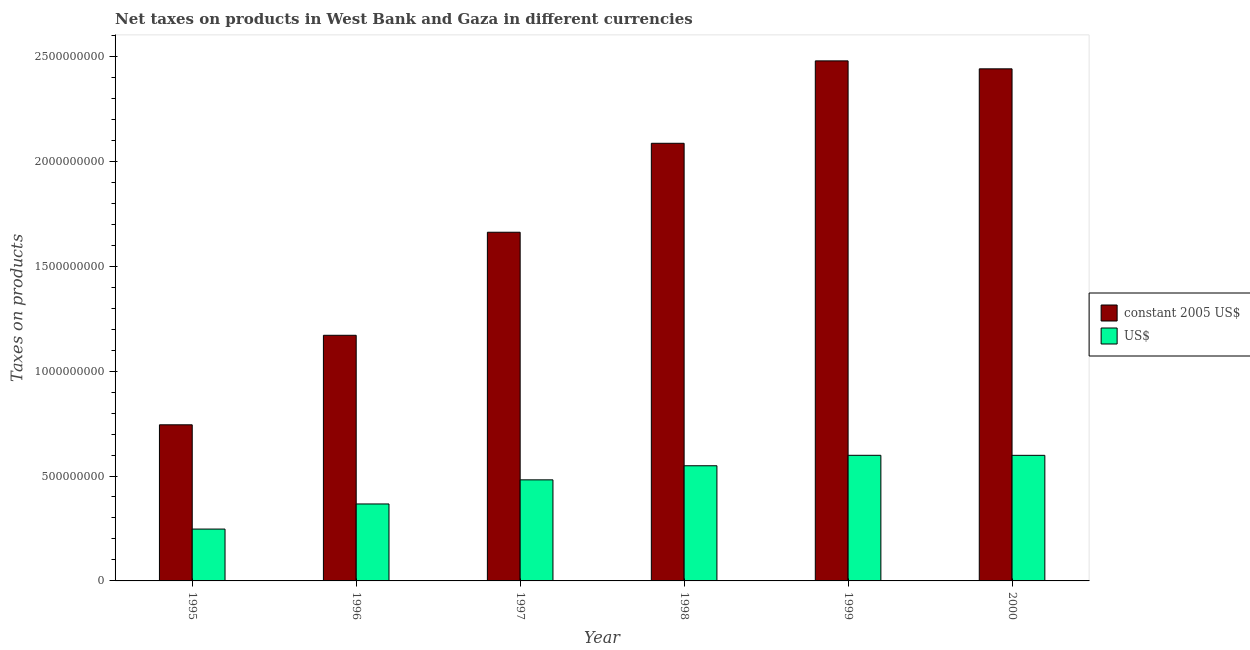How many groups of bars are there?
Your answer should be very brief. 6. Are the number of bars per tick equal to the number of legend labels?
Offer a terse response. Yes. Are the number of bars on each tick of the X-axis equal?
Make the answer very short. Yes. How many bars are there on the 4th tick from the left?
Make the answer very short. 2. How many bars are there on the 6th tick from the right?
Your answer should be compact. 2. What is the net taxes in us$ in 1996?
Keep it short and to the point. 3.67e+08. Across all years, what is the maximum net taxes in us$?
Your response must be concise. 5.99e+08. Across all years, what is the minimum net taxes in constant 2005 us$?
Make the answer very short. 7.44e+08. In which year was the net taxes in us$ maximum?
Your answer should be compact. 1999. In which year was the net taxes in us$ minimum?
Provide a succinct answer. 1995. What is the total net taxes in us$ in the graph?
Provide a short and direct response. 2.84e+09. What is the difference between the net taxes in constant 2005 us$ in 1996 and that in 1999?
Your answer should be compact. -1.31e+09. What is the difference between the net taxes in constant 2005 us$ in 1995 and the net taxes in us$ in 2000?
Give a very brief answer. -1.70e+09. What is the average net taxes in us$ per year?
Your response must be concise. 4.74e+08. In the year 1996, what is the difference between the net taxes in us$ and net taxes in constant 2005 us$?
Offer a very short reply. 0. In how many years, is the net taxes in constant 2005 us$ greater than 2400000000 units?
Your answer should be very brief. 2. What is the ratio of the net taxes in us$ in 1997 to that in 2000?
Ensure brevity in your answer.  0.8. Is the difference between the net taxes in constant 2005 us$ in 1996 and 1999 greater than the difference between the net taxes in us$ in 1996 and 1999?
Give a very brief answer. No. What is the difference between the highest and the second highest net taxes in us$?
Keep it short and to the point. 1.47e+05. What is the difference between the highest and the lowest net taxes in us$?
Offer a terse response. 3.52e+08. In how many years, is the net taxes in us$ greater than the average net taxes in us$ taken over all years?
Your response must be concise. 4. Is the sum of the net taxes in us$ in 1996 and 1998 greater than the maximum net taxes in constant 2005 us$ across all years?
Provide a short and direct response. Yes. What does the 2nd bar from the left in 1995 represents?
Provide a short and direct response. US$. What does the 2nd bar from the right in 1999 represents?
Your answer should be very brief. Constant 2005 us$. How many bars are there?
Your response must be concise. 12. Are all the bars in the graph horizontal?
Make the answer very short. No. How many years are there in the graph?
Keep it short and to the point. 6. What is the difference between two consecutive major ticks on the Y-axis?
Your response must be concise. 5.00e+08. Are the values on the major ticks of Y-axis written in scientific E-notation?
Your response must be concise. No. How many legend labels are there?
Provide a succinct answer. 2. What is the title of the graph?
Your response must be concise. Net taxes on products in West Bank and Gaza in different currencies. Does "Age 15+" appear as one of the legend labels in the graph?
Give a very brief answer. No. What is the label or title of the Y-axis?
Ensure brevity in your answer.  Taxes on products. What is the Taxes on products in constant 2005 US$ in 1995?
Your response must be concise. 7.44e+08. What is the Taxes on products in US$ in 1995?
Your answer should be very brief. 2.47e+08. What is the Taxes on products in constant 2005 US$ in 1996?
Your answer should be compact. 1.17e+09. What is the Taxes on products of US$ in 1996?
Provide a succinct answer. 3.67e+08. What is the Taxes on products in constant 2005 US$ in 1997?
Offer a very short reply. 1.66e+09. What is the Taxes on products in US$ in 1997?
Give a very brief answer. 4.82e+08. What is the Taxes on products in constant 2005 US$ in 1998?
Your response must be concise. 2.09e+09. What is the Taxes on products of US$ in 1998?
Give a very brief answer. 5.49e+08. What is the Taxes on products in constant 2005 US$ in 1999?
Provide a succinct answer. 2.48e+09. What is the Taxes on products of US$ in 1999?
Your answer should be compact. 5.99e+08. What is the Taxes on products in constant 2005 US$ in 2000?
Provide a short and direct response. 2.44e+09. What is the Taxes on products of US$ in 2000?
Provide a succinct answer. 5.99e+08. Across all years, what is the maximum Taxes on products of constant 2005 US$?
Keep it short and to the point. 2.48e+09. Across all years, what is the maximum Taxes on products in US$?
Give a very brief answer. 5.99e+08. Across all years, what is the minimum Taxes on products of constant 2005 US$?
Your response must be concise. 7.44e+08. Across all years, what is the minimum Taxes on products of US$?
Offer a very short reply. 2.47e+08. What is the total Taxes on products in constant 2005 US$ in the graph?
Give a very brief answer. 1.06e+1. What is the total Taxes on products of US$ in the graph?
Give a very brief answer. 2.84e+09. What is the difference between the Taxes on products in constant 2005 US$ in 1995 and that in 1996?
Your response must be concise. -4.27e+08. What is the difference between the Taxes on products in US$ in 1995 and that in 1996?
Give a very brief answer. -1.20e+08. What is the difference between the Taxes on products of constant 2005 US$ in 1995 and that in 1997?
Give a very brief answer. -9.18e+08. What is the difference between the Taxes on products of US$ in 1995 and that in 1997?
Ensure brevity in your answer.  -2.35e+08. What is the difference between the Taxes on products of constant 2005 US$ in 1995 and that in 1998?
Give a very brief answer. -1.34e+09. What is the difference between the Taxes on products in US$ in 1995 and that in 1998?
Offer a terse response. -3.02e+08. What is the difference between the Taxes on products of constant 2005 US$ in 1995 and that in 1999?
Your response must be concise. -1.73e+09. What is the difference between the Taxes on products of US$ in 1995 and that in 1999?
Offer a very short reply. -3.52e+08. What is the difference between the Taxes on products of constant 2005 US$ in 1995 and that in 2000?
Your answer should be very brief. -1.70e+09. What is the difference between the Taxes on products of US$ in 1995 and that in 2000?
Give a very brief answer. -3.52e+08. What is the difference between the Taxes on products of constant 2005 US$ in 1996 and that in 1997?
Your response must be concise. -4.91e+08. What is the difference between the Taxes on products of US$ in 1996 and that in 1997?
Offer a very short reply. -1.15e+08. What is the difference between the Taxes on products in constant 2005 US$ in 1996 and that in 1998?
Provide a short and direct response. -9.15e+08. What is the difference between the Taxes on products of US$ in 1996 and that in 1998?
Provide a short and direct response. -1.82e+08. What is the difference between the Taxes on products of constant 2005 US$ in 1996 and that in 1999?
Give a very brief answer. -1.31e+09. What is the difference between the Taxes on products of US$ in 1996 and that in 1999?
Provide a succinct answer. -2.32e+08. What is the difference between the Taxes on products of constant 2005 US$ in 1996 and that in 2000?
Make the answer very short. -1.27e+09. What is the difference between the Taxes on products in US$ in 1996 and that in 2000?
Ensure brevity in your answer.  -2.32e+08. What is the difference between the Taxes on products in constant 2005 US$ in 1997 and that in 1998?
Keep it short and to the point. -4.24e+08. What is the difference between the Taxes on products of US$ in 1997 and that in 1998?
Ensure brevity in your answer.  -6.71e+07. What is the difference between the Taxes on products in constant 2005 US$ in 1997 and that in 1999?
Your answer should be compact. -8.17e+08. What is the difference between the Taxes on products of US$ in 1997 and that in 1999?
Offer a terse response. -1.17e+08. What is the difference between the Taxes on products in constant 2005 US$ in 1997 and that in 2000?
Keep it short and to the point. -7.79e+08. What is the difference between the Taxes on products in US$ in 1997 and that in 2000?
Make the answer very short. -1.17e+08. What is the difference between the Taxes on products in constant 2005 US$ in 1998 and that in 1999?
Ensure brevity in your answer.  -3.93e+08. What is the difference between the Taxes on products of US$ in 1998 and that in 1999?
Keep it short and to the point. -4.99e+07. What is the difference between the Taxes on products of constant 2005 US$ in 1998 and that in 2000?
Offer a very short reply. -3.55e+08. What is the difference between the Taxes on products in US$ in 1998 and that in 2000?
Provide a short and direct response. -4.97e+07. What is the difference between the Taxes on products of constant 2005 US$ in 1999 and that in 2000?
Offer a terse response. 3.80e+07. What is the difference between the Taxes on products of US$ in 1999 and that in 2000?
Keep it short and to the point. 1.47e+05. What is the difference between the Taxes on products in constant 2005 US$ in 1995 and the Taxes on products in US$ in 1996?
Provide a short and direct response. 3.77e+08. What is the difference between the Taxes on products of constant 2005 US$ in 1995 and the Taxes on products of US$ in 1997?
Your answer should be compact. 2.62e+08. What is the difference between the Taxes on products in constant 2005 US$ in 1995 and the Taxes on products in US$ in 1998?
Provide a succinct answer. 1.95e+08. What is the difference between the Taxes on products in constant 2005 US$ in 1995 and the Taxes on products in US$ in 1999?
Keep it short and to the point. 1.45e+08. What is the difference between the Taxes on products of constant 2005 US$ in 1995 and the Taxes on products of US$ in 2000?
Offer a terse response. 1.45e+08. What is the difference between the Taxes on products of constant 2005 US$ in 1996 and the Taxes on products of US$ in 1997?
Provide a short and direct response. 6.89e+08. What is the difference between the Taxes on products in constant 2005 US$ in 1996 and the Taxes on products in US$ in 1998?
Keep it short and to the point. 6.22e+08. What is the difference between the Taxes on products of constant 2005 US$ in 1996 and the Taxes on products of US$ in 1999?
Offer a terse response. 5.72e+08. What is the difference between the Taxes on products in constant 2005 US$ in 1996 and the Taxes on products in US$ in 2000?
Ensure brevity in your answer.  5.72e+08. What is the difference between the Taxes on products in constant 2005 US$ in 1997 and the Taxes on products in US$ in 1998?
Your response must be concise. 1.11e+09. What is the difference between the Taxes on products of constant 2005 US$ in 1997 and the Taxes on products of US$ in 1999?
Keep it short and to the point. 1.06e+09. What is the difference between the Taxes on products in constant 2005 US$ in 1997 and the Taxes on products in US$ in 2000?
Your answer should be very brief. 1.06e+09. What is the difference between the Taxes on products in constant 2005 US$ in 1998 and the Taxes on products in US$ in 1999?
Your response must be concise. 1.49e+09. What is the difference between the Taxes on products of constant 2005 US$ in 1998 and the Taxes on products of US$ in 2000?
Your answer should be compact. 1.49e+09. What is the difference between the Taxes on products in constant 2005 US$ in 1999 and the Taxes on products in US$ in 2000?
Provide a short and direct response. 1.88e+09. What is the average Taxes on products of constant 2005 US$ per year?
Give a very brief answer. 1.76e+09. What is the average Taxes on products of US$ per year?
Ensure brevity in your answer.  4.74e+08. In the year 1995, what is the difference between the Taxes on products of constant 2005 US$ and Taxes on products of US$?
Your answer should be very brief. 4.97e+08. In the year 1996, what is the difference between the Taxes on products of constant 2005 US$ and Taxes on products of US$?
Your answer should be very brief. 8.04e+08. In the year 1997, what is the difference between the Taxes on products of constant 2005 US$ and Taxes on products of US$?
Your answer should be very brief. 1.18e+09. In the year 1998, what is the difference between the Taxes on products of constant 2005 US$ and Taxes on products of US$?
Provide a short and direct response. 1.54e+09. In the year 1999, what is the difference between the Taxes on products in constant 2005 US$ and Taxes on products in US$?
Your answer should be very brief. 1.88e+09. In the year 2000, what is the difference between the Taxes on products of constant 2005 US$ and Taxes on products of US$?
Offer a very short reply. 1.84e+09. What is the ratio of the Taxes on products in constant 2005 US$ in 1995 to that in 1996?
Your response must be concise. 0.64. What is the ratio of the Taxes on products in US$ in 1995 to that in 1996?
Your answer should be compact. 0.67. What is the ratio of the Taxes on products of constant 2005 US$ in 1995 to that in 1997?
Provide a short and direct response. 0.45. What is the ratio of the Taxes on products in US$ in 1995 to that in 1997?
Give a very brief answer. 0.51. What is the ratio of the Taxes on products of constant 2005 US$ in 1995 to that in 1998?
Your answer should be compact. 0.36. What is the ratio of the Taxes on products of US$ in 1995 to that in 1998?
Offer a very short reply. 0.45. What is the ratio of the Taxes on products in constant 2005 US$ in 1995 to that in 1999?
Your answer should be very brief. 0.3. What is the ratio of the Taxes on products of US$ in 1995 to that in 1999?
Keep it short and to the point. 0.41. What is the ratio of the Taxes on products in constant 2005 US$ in 1995 to that in 2000?
Give a very brief answer. 0.3. What is the ratio of the Taxes on products in US$ in 1995 to that in 2000?
Ensure brevity in your answer.  0.41. What is the ratio of the Taxes on products of constant 2005 US$ in 1996 to that in 1997?
Provide a succinct answer. 0.7. What is the ratio of the Taxes on products in US$ in 1996 to that in 1997?
Provide a short and direct response. 0.76. What is the ratio of the Taxes on products in constant 2005 US$ in 1996 to that in 1998?
Your answer should be very brief. 0.56. What is the ratio of the Taxes on products in US$ in 1996 to that in 1998?
Provide a short and direct response. 0.67. What is the ratio of the Taxes on products of constant 2005 US$ in 1996 to that in 1999?
Provide a short and direct response. 0.47. What is the ratio of the Taxes on products of US$ in 1996 to that in 1999?
Provide a succinct answer. 0.61. What is the ratio of the Taxes on products in constant 2005 US$ in 1996 to that in 2000?
Offer a very short reply. 0.48. What is the ratio of the Taxes on products of US$ in 1996 to that in 2000?
Give a very brief answer. 0.61. What is the ratio of the Taxes on products of constant 2005 US$ in 1997 to that in 1998?
Ensure brevity in your answer.  0.8. What is the ratio of the Taxes on products in US$ in 1997 to that in 1998?
Offer a very short reply. 0.88. What is the ratio of the Taxes on products in constant 2005 US$ in 1997 to that in 1999?
Offer a terse response. 0.67. What is the ratio of the Taxes on products of US$ in 1997 to that in 1999?
Offer a very short reply. 0.8. What is the ratio of the Taxes on products of constant 2005 US$ in 1997 to that in 2000?
Ensure brevity in your answer.  0.68. What is the ratio of the Taxes on products of US$ in 1997 to that in 2000?
Make the answer very short. 0.8. What is the ratio of the Taxes on products of constant 2005 US$ in 1998 to that in 1999?
Your answer should be compact. 0.84. What is the ratio of the Taxes on products in constant 2005 US$ in 1998 to that in 2000?
Offer a very short reply. 0.85. What is the ratio of the Taxes on products of US$ in 1998 to that in 2000?
Give a very brief answer. 0.92. What is the ratio of the Taxes on products in constant 2005 US$ in 1999 to that in 2000?
Your answer should be compact. 1.02. What is the ratio of the Taxes on products in US$ in 1999 to that in 2000?
Offer a terse response. 1. What is the difference between the highest and the second highest Taxes on products in constant 2005 US$?
Give a very brief answer. 3.80e+07. What is the difference between the highest and the second highest Taxes on products of US$?
Give a very brief answer. 1.47e+05. What is the difference between the highest and the lowest Taxes on products in constant 2005 US$?
Ensure brevity in your answer.  1.73e+09. What is the difference between the highest and the lowest Taxes on products of US$?
Offer a very short reply. 3.52e+08. 